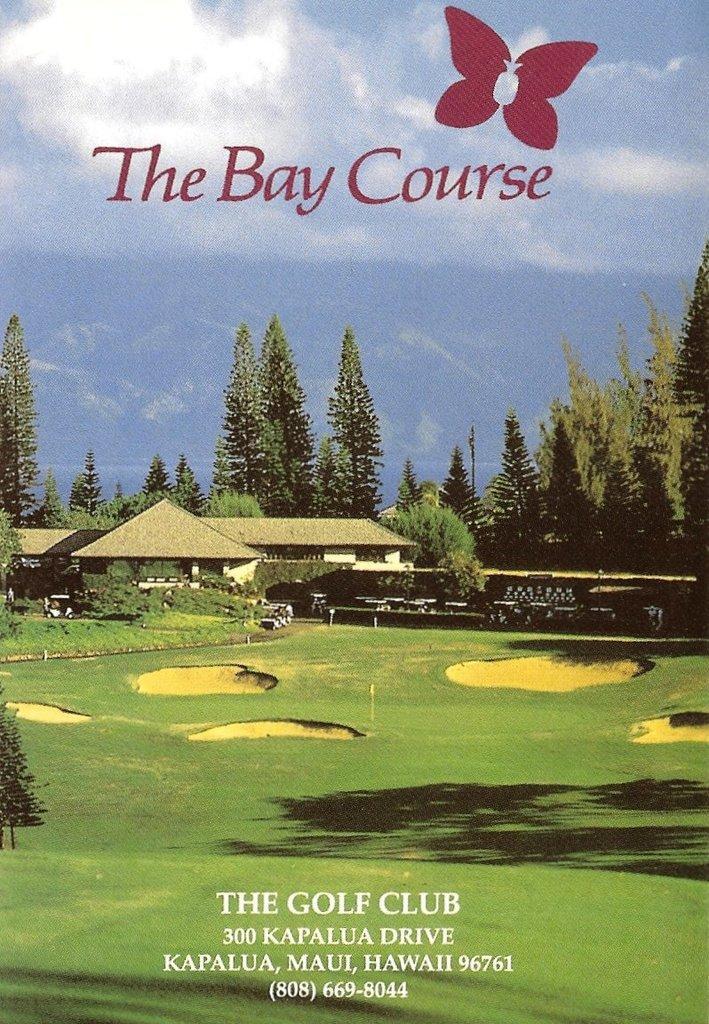<image>
Give a short and clear explanation of the subsequent image. Poster for The Golf Club which is located on Kapalua Drive. 